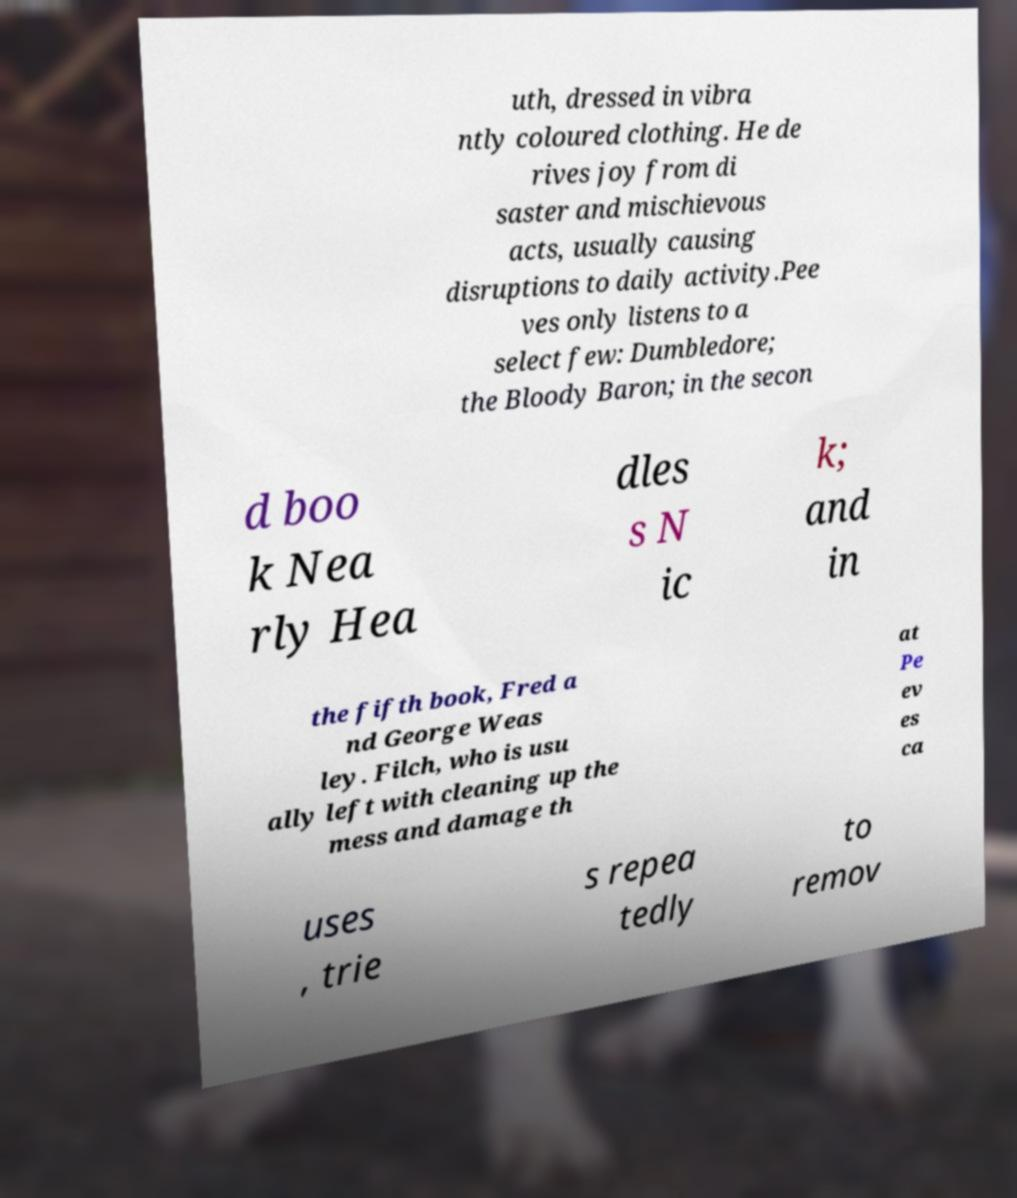Could you extract and type out the text from this image? uth, dressed in vibra ntly coloured clothing. He de rives joy from di saster and mischievous acts, usually causing disruptions to daily activity.Pee ves only listens to a select few: Dumbledore; the Bloody Baron; in the secon d boo k Nea rly Hea dles s N ic k; and in the fifth book, Fred a nd George Weas ley. Filch, who is usu ally left with cleaning up the mess and damage th at Pe ev es ca uses , trie s repea tedly to remov 